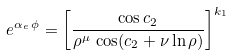<formula> <loc_0><loc_0><loc_500><loc_500>e ^ { \alpha _ { e } \, \phi } = \left [ { \frac { \cos { c _ { 2 } } } { \rho ^ { \mu } \, \cos ( { c _ { 2 } + \nu \ln \rho ) } } } \right ] ^ { k _ { 1 } }</formula> 